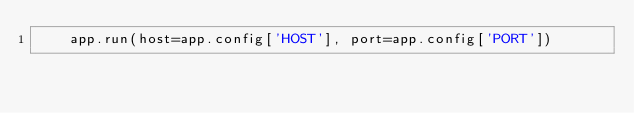Convert code to text. <code><loc_0><loc_0><loc_500><loc_500><_Python_>    app.run(host=app.config['HOST'], port=app.config['PORT'])
</code> 